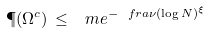Convert formula to latex. <formula><loc_0><loc_0><loc_500><loc_500>\P ( \Omega ^ { c } ) \, \leq \, \ m e ^ { - \ f r a \nu ( \log N ) ^ { \xi } }</formula> 